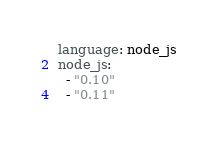Convert code to text. <code><loc_0><loc_0><loc_500><loc_500><_YAML_>language: node_js
node_js:
  - "0.10"
  - "0.11"</code> 